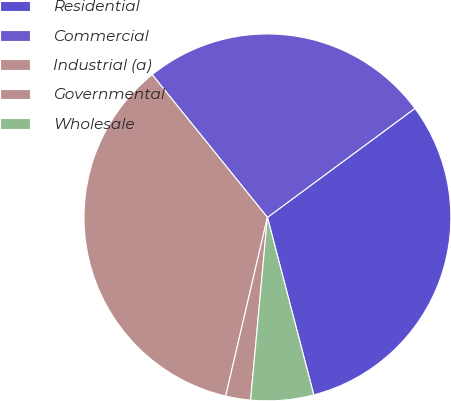Convert chart to OTSL. <chart><loc_0><loc_0><loc_500><loc_500><pie_chart><fcel>Residential<fcel>Commercial<fcel>Industrial (a)<fcel>Governmental<fcel>Wholesale<nl><fcel>31.06%<fcel>25.68%<fcel>35.54%<fcel>2.19%<fcel>5.53%<nl></chart> 